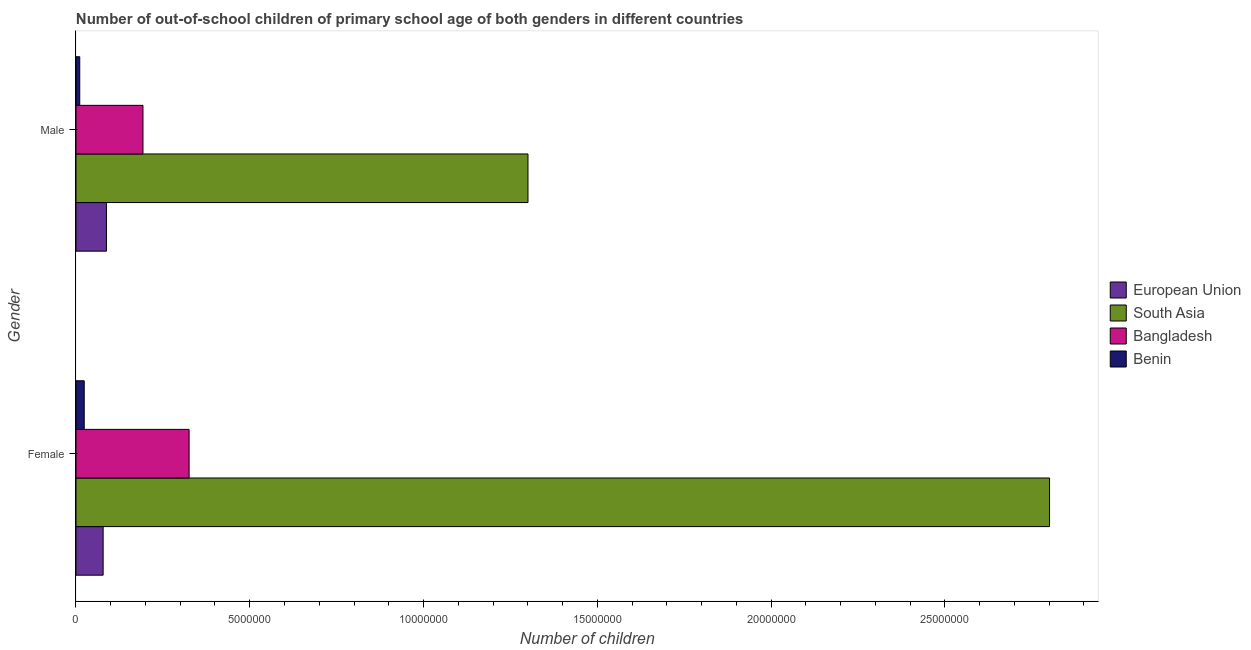How many different coloured bars are there?
Your answer should be compact. 4. How many groups of bars are there?
Your response must be concise. 2. Are the number of bars per tick equal to the number of legend labels?
Provide a succinct answer. Yes. Are the number of bars on each tick of the Y-axis equal?
Offer a terse response. Yes. How many bars are there on the 1st tick from the top?
Provide a short and direct response. 4. How many bars are there on the 2nd tick from the bottom?
Give a very brief answer. 4. What is the number of male out-of-school students in European Union?
Offer a very short reply. 8.77e+05. Across all countries, what is the maximum number of female out-of-school students?
Provide a short and direct response. 2.80e+07. Across all countries, what is the minimum number of male out-of-school students?
Keep it short and to the point. 1.08e+05. In which country was the number of male out-of-school students minimum?
Your response must be concise. Benin. What is the total number of female out-of-school students in the graph?
Ensure brevity in your answer.  3.23e+07. What is the difference between the number of female out-of-school students in Benin and that in South Asia?
Your response must be concise. -2.78e+07. What is the difference between the number of male out-of-school students in South Asia and the number of female out-of-school students in Bangladesh?
Make the answer very short. 9.75e+06. What is the average number of male out-of-school students per country?
Provide a short and direct response. 3.98e+06. What is the difference between the number of female out-of-school students and number of male out-of-school students in South Asia?
Ensure brevity in your answer.  1.50e+07. In how many countries, is the number of female out-of-school students greater than 7000000 ?
Your answer should be compact. 1. What is the ratio of the number of female out-of-school students in South Asia to that in Bangladesh?
Your answer should be very brief. 8.61. Is the number of male out-of-school students in South Asia less than that in European Union?
Make the answer very short. No. In how many countries, is the number of female out-of-school students greater than the average number of female out-of-school students taken over all countries?
Ensure brevity in your answer.  1. What does the 3rd bar from the bottom in Male represents?
Provide a succinct answer. Bangladesh. How many countries are there in the graph?
Offer a very short reply. 4. Does the graph contain any zero values?
Your answer should be compact. No. Where does the legend appear in the graph?
Your response must be concise. Center right. How many legend labels are there?
Provide a short and direct response. 4. What is the title of the graph?
Provide a short and direct response. Number of out-of-school children of primary school age of both genders in different countries. Does "United States" appear as one of the legend labels in the graph?
Offer a terse response. No. What is the label or title of the X-axis?
Give a very brief answer. Number of children. What is the label or title of the Y-axis?
Your response must be concise. Gender. What is the Number of children in European Union in Female?
Your answer should be very brief. 7.81e+05. What is the Number of children in South Asia in Female?
Your response must be concise. 2.80e+07. What is the Number of children of Bangladesh in Female?
Ensure brevity in your answer.  3.26e+06. What is the Number of children of Benin in Female?
Keep it short and to the point. 2.37e+05. What is the Number of children of European Union in Male?
Keep it short and to the point. 8.77e+05. What is the Number of children in South Asia in Male?
Your answer should be very brief. 1.30e+07. What is the Number of children of Bangladesh in Male?
Give a very brief answer. 1.93e+06. What is the Number of children of Benin in Male?
Provide a short and direct response. 1.08e+05. Across all Gender, what is the maximum Number of children of European Union?
Make the answer very short. 8.77e+05. Across all Gender, what is the maximum Number of children in South Asia?
Offer a very short reply. 2.80e+07. Across all Gender, what is the maximum Number of children of Bangladesh?
Provide a short and direct response. 3.26e+06. Across all Gender, what is the maximum Number of children in Benin?
Your answer should be very brief. 2.37e+05. Across all Gender, what is the minimum Number of children in European Union?
Keep it short and to the point. 7.81e+05. Across all Gender, what is the minimum Number of children in South Asia?
Your response must be concise. 1.30e+07. Across all Gender, what is the minimum Number of children in Bangladesh?
Offer a terse response. 1.93e+06. Across all Gender, what is the minimum Number of children in Benin?
Offer a terse response. 1.08e+05. What is the total Number of children of European Union in the graph?
Your answer should be very brief. 1.66e+06. What is the total Number of children in South Asia in the graph?
Your answer should be compact. 4.10e+07. What is the total Number of children of Bangladesh in the graph?
Make the answer very short. 5.18e+06. What is the total Number of children in Benin in the graph?
Give a very brief answer. 3.45e+05. What is the difference between the Number of children of European Union in Female and that in Male?
Offer a terse response. -9.55e+04. What is the difference between the Number of children of South Asia in Female and that in Male?
Keep it short and to the point. 1.50e+07. What is the difference between the Number of children in Bangladesh in Female and that in Male?
Offer a terse response. 1.33e+06. What is the difference between the Number of children of Benin in Female and that in Male?
Provide a succinct answer. 1.29e+05. What is the difference between the Number of children in European Union in Female and the Number of children in South Asia in Male?
Your answer should be compact. -1.22e+07. What is the difference between the Number of children of European Union in Female and the Number of children of Bangladesh in Male?
Make the answer very short. -1.15e+06. What is the difference between the Number of children in European Union in Female and the Number of children in Benin in Male?
Your answer should be compact. 6.73e+05. What is the difference between the Number of children in South Asia in Female and the Number of children in Bangladesh in Male?
Make the answer very short. 2.61e+07. What is the difference between the Number of children in South Asia in Female and the Number of children in Benin in Male?
Provide a succinct answer. 2.79e+07. What is the difference between the Number of children of Bangladesh in Female and the Number of children of Benin in Male?
Offer a terse response. 3.15e+06. What is the average Number of children of European Union per Gender?
Provide a succinct answer. 8.29e+05. What is the average Number of children of South Asia per Gender?
Keep it short and to the point. 2.05e+07. What is the average Number of children of Bangladesh per Gender?
Provide a short and direct response. 2.59e+06. What is the average Number of children of Benin per Gender?
Keep it short and to the point. 1.73e+05. What is the difference between the Number of children of European Union and Number of children of South Asia in Female?
Ensure brevity in your answer.  -2.72e+07. What is the difference between the Number of children of European Union and Number of children of Bangladesh in Female?
Give a very brief answer. -2.47e+06. What is the difference between the Number of children of European Union and Number of children of Benin in Female?
Your answer should be very brief. 5.44e+05. What is the difference between the Number of children of South Asia and Number of children of Bangladesh in Female?
Keep it short and to the point. 2.48e+07. What is the difference between the Number of children in South Asia and Number of children in Benin in Female?
Provide a short and direct response. 2.78e+07. What is the difference between the Number of children in Bangladesh and Number of children in Benin in Female?
Provide a short and direct response. 3.02e+06. What is the difference between the Number of children of European Union and Number of children of South Asia in Male?
Your answer should be compact. -1.21e+07. What is the difference between the Number of children of European Union and Number of children of Bangladesh in Male?
Ensure brevity in your answer.  -1.05e+06. What is the difference between the Number of children in European Union and Number of children in Benin in Male?
Provide a succinct answer. 7.69e+05. What is the difference between the Number of children of South Asia and Number of children of Bangladesh in Male?
Provide a succinct answer. 1.11e+07. What is the difference between the Number of children in South Asia and Number of children in Benin in Male?
Give a very brief answer. 1.29e+07. What is the difference between the Number of children in Bangladesh and Number of children in Benin in Male?
Your answer should be compact. 1.82e+06. What is the ratio of the Number of children in European Union in Female to that in Male?
Give a very brief answer. 0.89. What is the ratio of the Number of children in South Asia in Female to that in Male?
Your answer should be very brief. 2.15. What is the ratio of the Number of children in Bangladesh in Female to that in Male?
Keep it short and to the point. 1.69. What is the ratio of the Number of children in Benin in Female to that in Male?
Provide a short and direct response. 2.19. What is the difference between the highest and the second highest Number of children in European Union?
Your response must be concise. 9.55e+04. What is the difference between the highest and the second highest Number of children of South Asia?
Keep it short and to the point. 1.50e+07. What is the difference between the highest and the second highest Number of children of Bangladesh?
Provide a succinct answer. 1.33e+06. What is the difference between the highest and the second highest Number of children of Benin?
Give a very brief answer. 1.29e+05. What is the difference between the highest and the lowest Number of children in European Union?
Offer a very short reply. 9.55e+04. What is the difference between the highest and the lowest Number of children in South Asia?
Your response must be concise. 1.50e+07. What is the difference between the highest and the lowest Number of children of Bangladesh?
Your answer should be very brief. 1.33e+06. What is the difference between the highest and the lowest Number of children in Benin?
Offer a very short reply. 1.29e+05. 